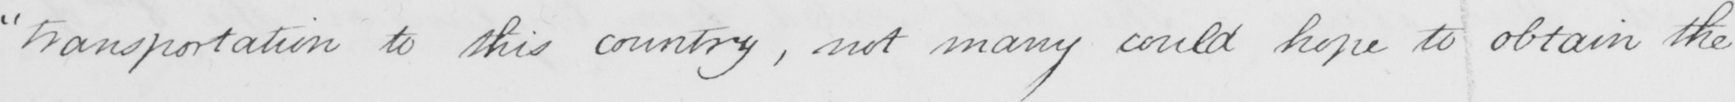What text is written in this handwritten line? " transportation to this country , not many could hope to obtain the 